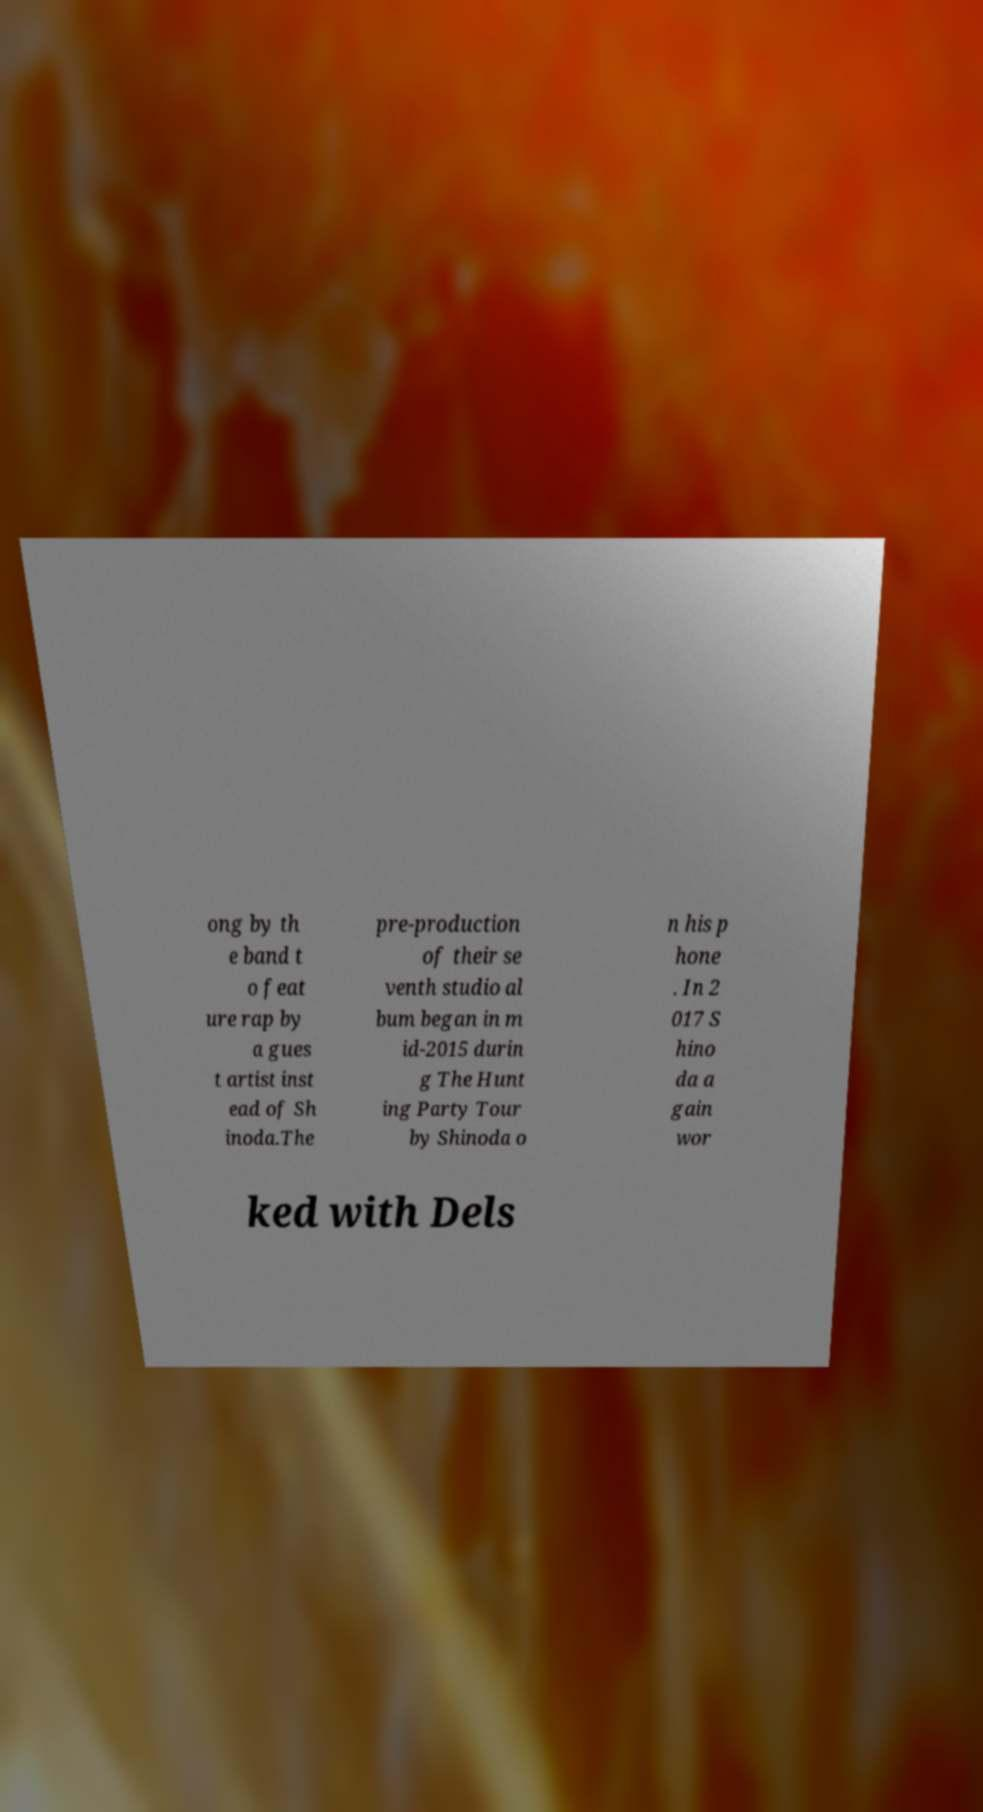Please identify and transcribe the text found in this image. ong by th e band t o feat ure rap by a gues t artist inst ead of Sh inoda.The pre-production of their se venth studio al bum began in m id-2015 durin g The Hunt ing Party Tour by Shinoda o n his p hone . In 2 017 S hino da a gain wor ked with Dels 